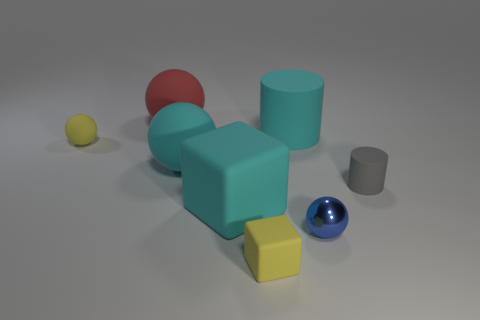What can you infer about the lighting and shadows in this scene? The scene appears to be illuminated by a diffuse light source, given the soft and faint shadows cast by the objects. The direction of the shadows suggests the light is coming from the upper left side of the frame, casting shadows predominantly to the right and slightly behind the objects. The softness of the shadows indicates the light is not overly harsh, which helps to create a calm and even setting. 